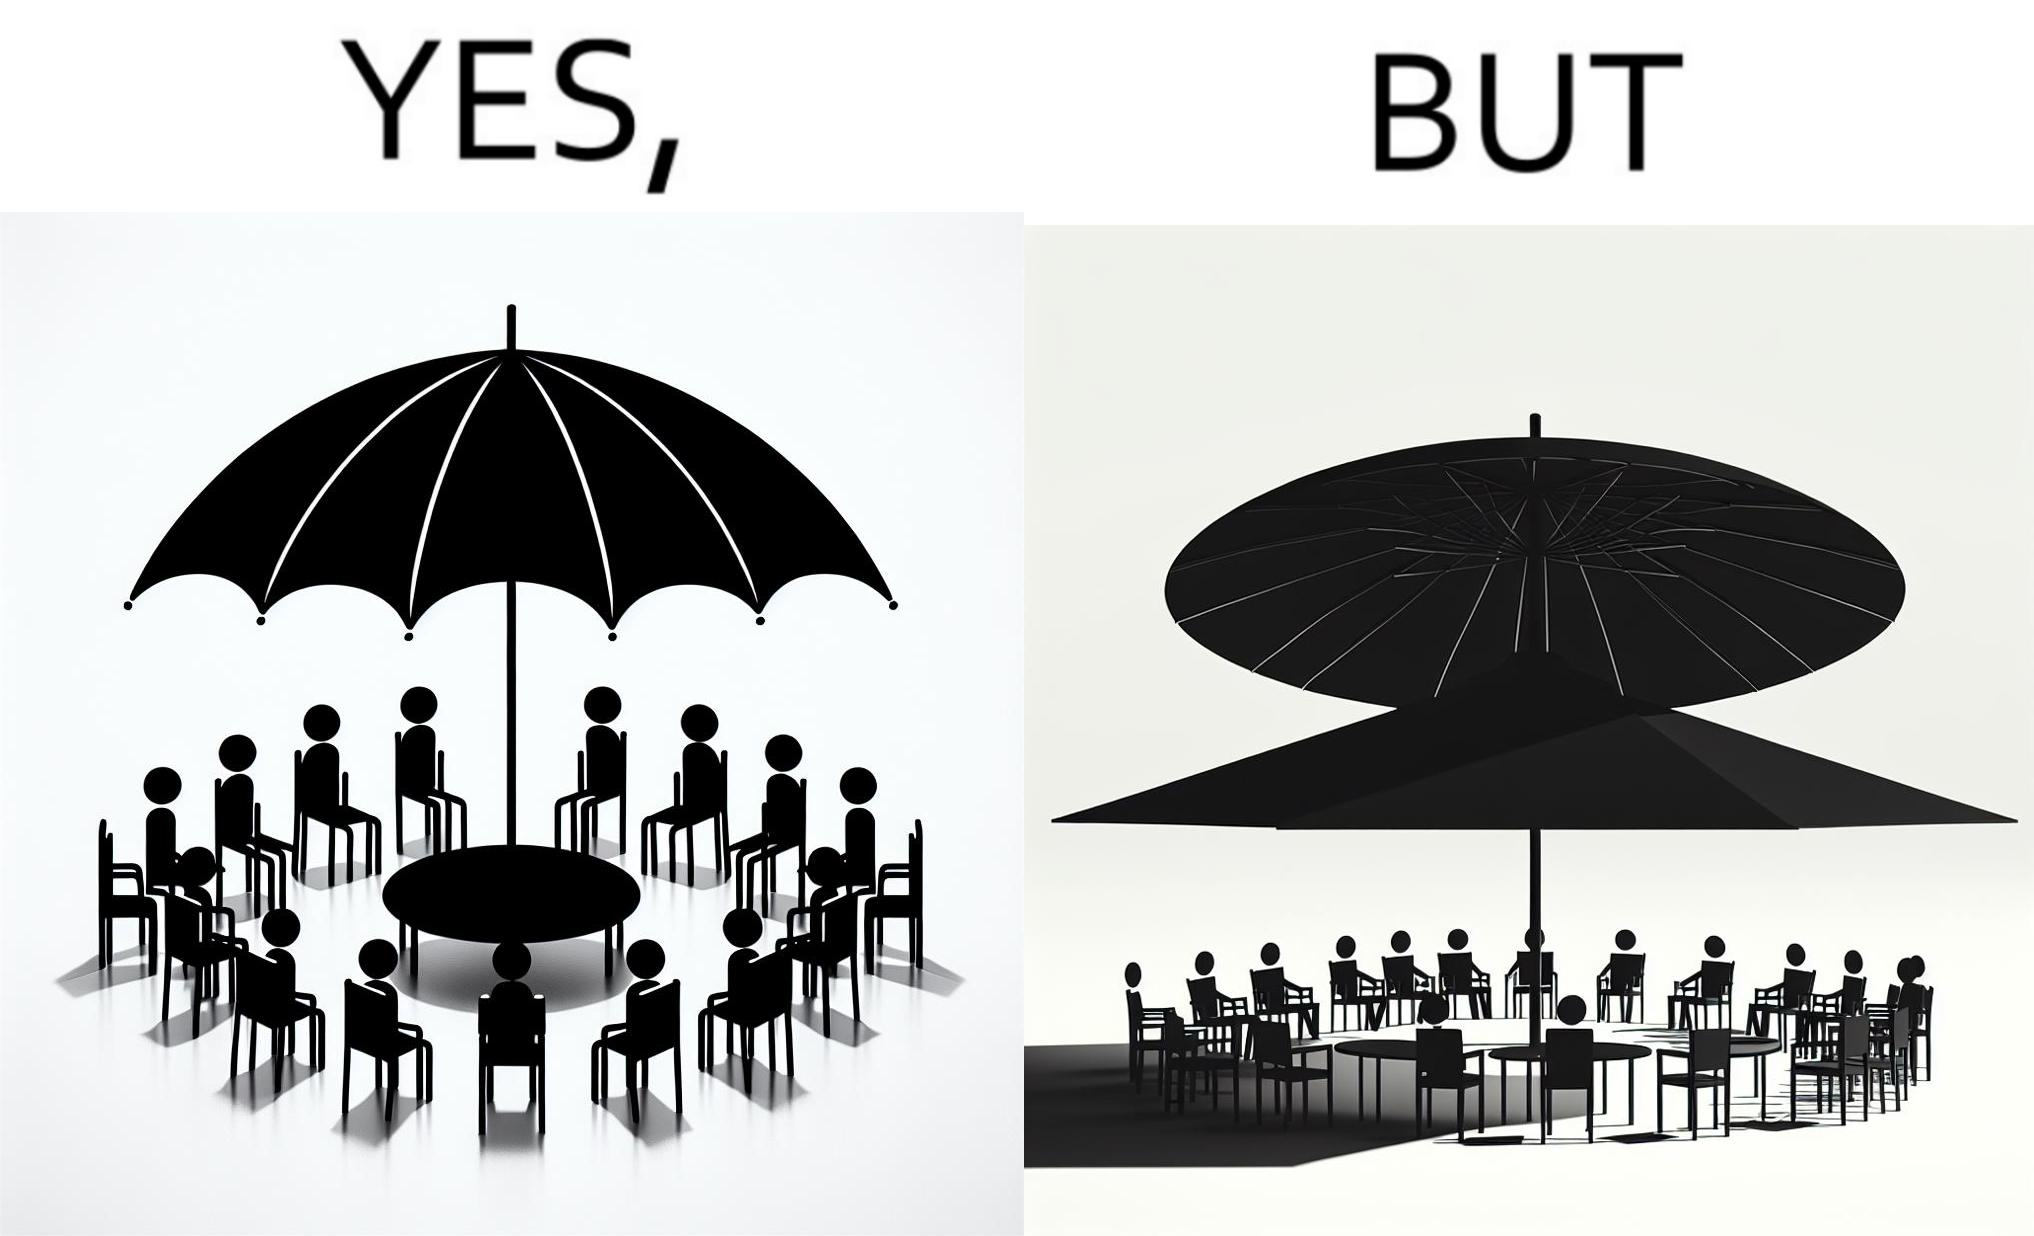Does this image contain satire or humor? Yes, this image is satirical. 